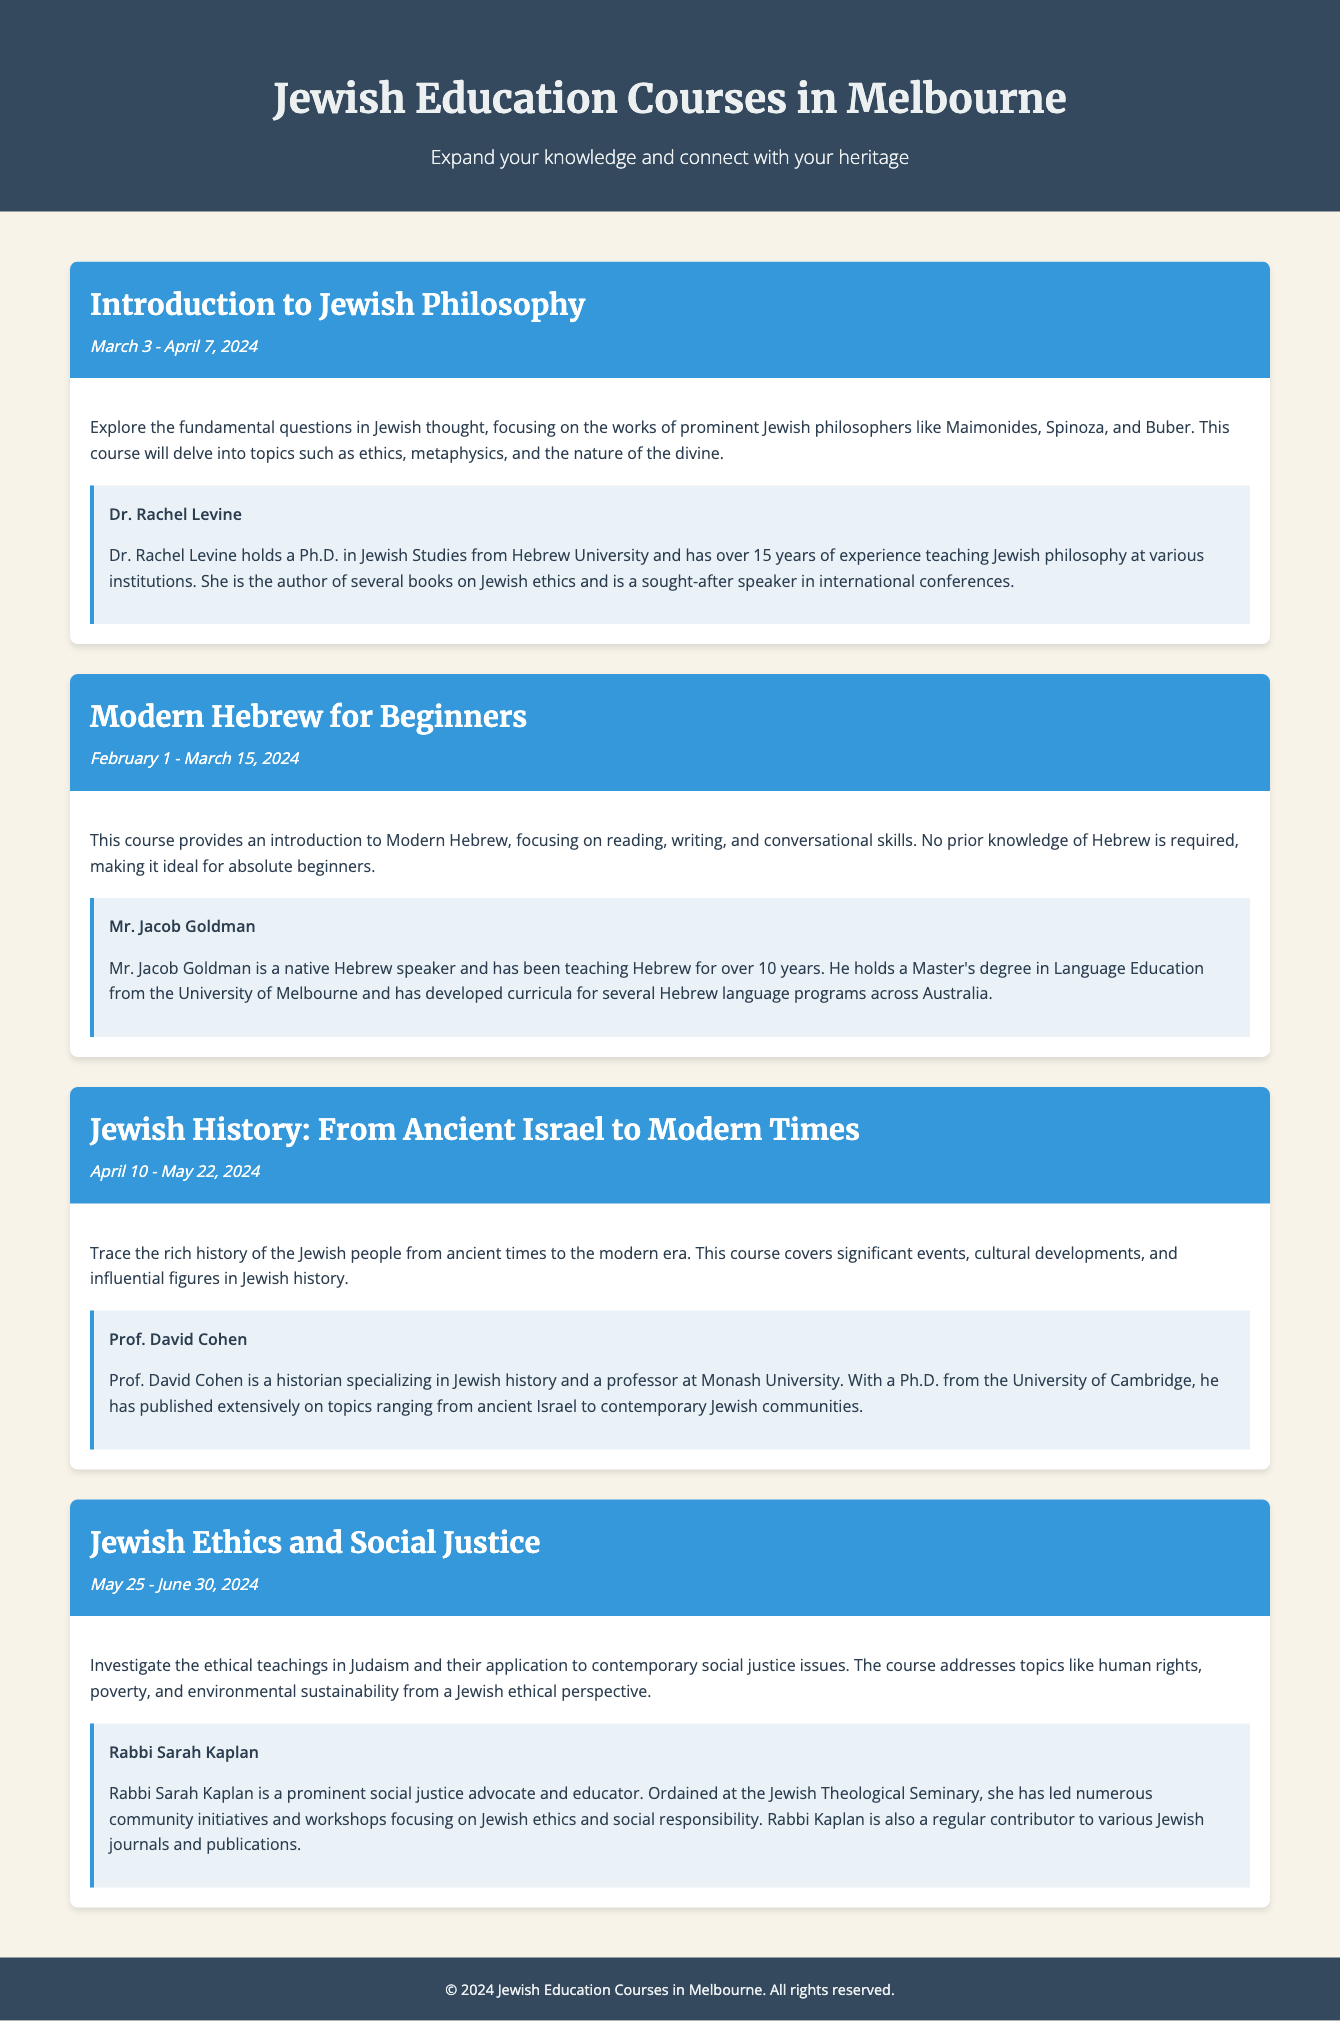What is the title of the first course? The first course listed in the document is "Introduction to Jewish Philosophy."
Answer: Introduction to Jewish Philosophy What are the dates for the "Modern Hebrew for Beginners" course? The dates for the "Modern Hebrew for Beginners" course are February 1 - March 15, 2024.
Answer: February 1 - March 15, 2024 Who is the instructor for the "Jewish History: From Ancient Israel to Modern Times" course? The instructor for this course is Prof. David Cohen.
Answer: Prof. David Cohen How many years of experience does Dr. Rachel Levine have? Dr. Rachel Levine has over 15 years of experience teaching Jewish philosophy.
Answer: Over 15 years What is the overarching theme of the "Jewish Ethics and Social Justice" course? The course investigates the ethical teachings in Judaism as they relate to contemporary social justice issues.
Answer: Ethical teachings in Judaism and social justice How many courses are offered in the catalogue? There are four courses listed in the document.
Answer: Four courses What type of degree does Mr. Jacob Goldman hold? Mr. Jacob Goldman holds a Master's degree in Language Education.
Answer: Master's degree in Language Education What is the focus of the "Introduction to Jewish Philosophy" course? The focus is on exploring fundamental questions in Jewish thought and prominent philosophers.
Answer: Fundamental questions in Jewish thought 